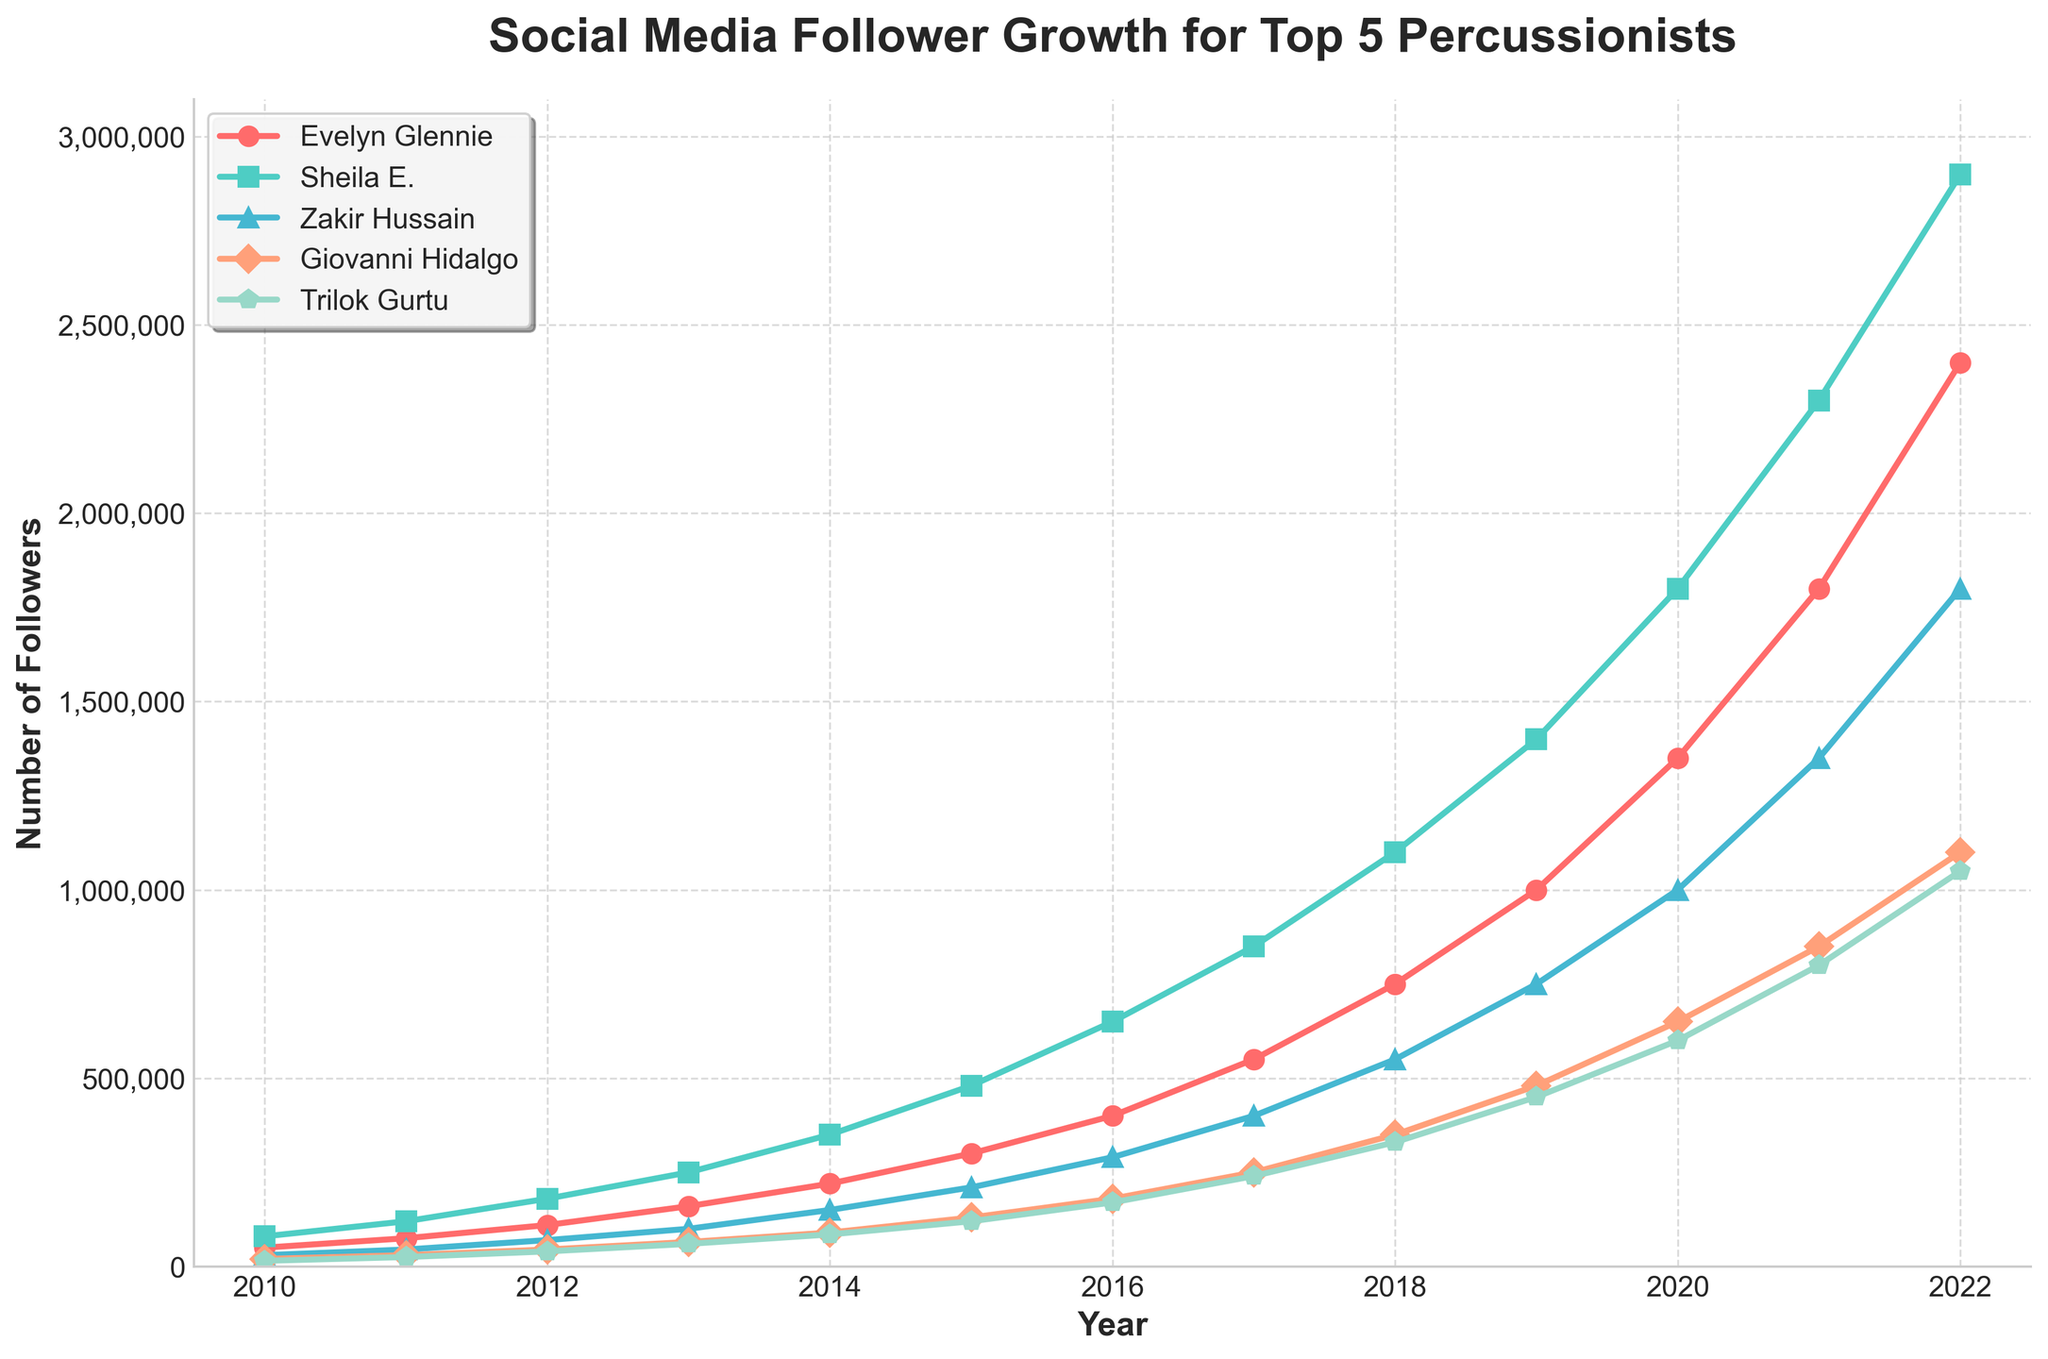Which percussionist has the most followers in 2022? To find the percussionist with the most followers in 2022, look at the highest point on the vertical axis for the year 2022. Sheila E. has the highest value, reaching 2,900,000.
Answer: Sheila E What is the difference in the number of followers between Zakir Hussain and Trilok Gurtu in 2021? Find the number of followers for Zakir Hussain and Trilok Gurtu in 2021. Zakir Hussain has 1,350,000 followers and Trilok Gurtu has 800,000 followers. Subtract Trilok's followers from Zakir's (1,350,000 - 800,000).
Answer: 550,000 Which two percussionists show the highest and lowest follower growth from 2010 to 2022? Calculate the total follower growth for each percussionist by subtracting the number of followers in 2010 from the number of followers in 2022. Sheila E. shows the highest growth (2,900,000 - 80,000 = 2,820,000), and Trilok Gurtu shows the lowest growth (1,050,000 - 15,000 = 1,035,000).
Answer: Sheila E. (highest), Trilok Gurtu (lowest) In which year did Evelyn Glennie surpass 1,000,000 followers? Identify the year when Evelyn Glennie’s follower count exceeded 1,000,000. In 2019, Evelyn Glennie reached 1,000,000 followers.
Answer: 2019 By how much did Giovanni Hidalgo's followers increase from 2015 to 2020? Giovanni Hidalgo had 130,000 followers in 2015 and 650,000 followers in 2020. The increase is calculated by subtracting the 2015 value from the 2020 value (650,000 - 130,000).
Answer: 520,000 How many percussionists had at least 1,000,000 followers by 2019? Count the number of percussionists whose follower count reached or exceeded 1,000,000 in 2019. Giovanni Hidalgo has 480,000 followers, so only Evelyn Glennie (1,000,000), Sheila E. (1,400,000), and Zakir Hussain (750,000) are above 1,000,000. So, there are 2 percussionists.
Answer: 2 What’s the average number of followers for all percussionists in 2018? Sum the number of followers for all percussionists in 2018 and divide by the number of percussionists. (750,000 + 1,100,000 + 550,000 + 350,000 + 330,000) = 3,080,000. Divide 3,080,000 by 5.
Answer: 616,000 